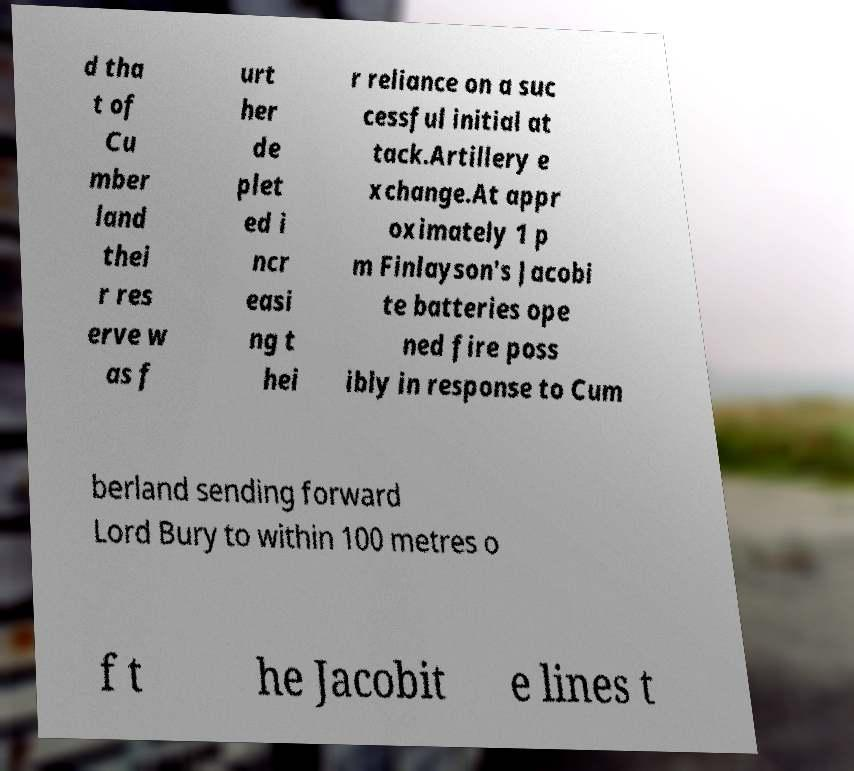There's text embedded in this image that I need extracted. Can you transcribe it verbatim? d tha t of Cu mber land thei r res erve w as f urt her de plet ed i ncr easi ng t hei r reliance on a suc cessful initial at tack.Artillery e xchange.At appr oximately 1 p m Finlayson's Jacobi te batteries ope ned fire poss ibly in response to Cum berland sending forward Lord Bury to within 100 metres o f t he Jacobit e lines t 